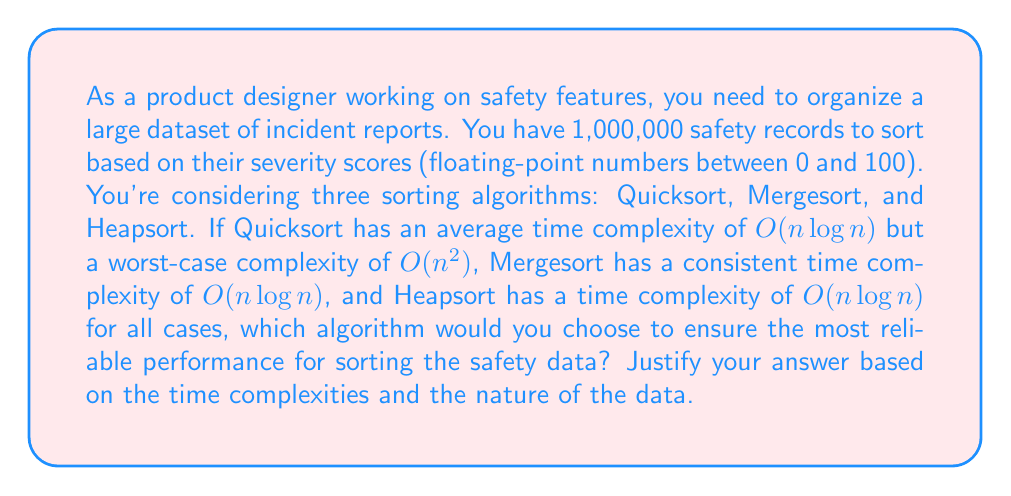Can you answer this question? To evaluate the performance of different sorting algorithms for organizing safety data, we need to consider both the time complexity and the nature of the data:

1. Quicksort:
   - Average case: $O(n \log n)$
   - Worst case: $O(n^2)$
   - Best for: Random data

2. Mergesort:
   - All cases: $O(n \log n)$
   - Best for: Linked lists, external sorting

3. Heapsort:
   - All cases: $O(n \log n)$
   - Best for: Arrays, limited memory

For 1,000,000 records:
- $n \log n \approx 1,000,000 \times \log_2(1,000,000) \approx 19,931,568$
- $n^2 = 1,000,000,000,000$

The worst-case scenario for Quicksort ($O(n^2)$) is significantly slower than the other algorithms. While Quicksort's average case is efficient, when dealing with safety data, reliability and consistency are crucial.

Both Mergesort and Heapsort guarantee $O(n \log n)$ performance in all cases, making them more reliable choices for safety-critical applications.

Heapsort has the advantage of sorting in-place, which is beneficial when dealing with large datasets and limited memory. It also has good cache performance, which can be important for large datasets.

Mergesort, while requiring additional space, is stable (preserves the relative order of equal elements) and performs well on linked lists, which could be beneficial if the data structure allows for easy insertion of new safety records.

Given the nature of safety data (critical information that needs reliable and consistent processing) and the large dataset size, Heapsort would be the most appropriate choice. It guarantees $O(n \log n)$ performance in all cases, sorts in-place (saving memory), and has good cache performance for large datasets.
Answer: Heapsort is the most suitable algorithm for sorting the safety data, as it guarantees $O(n \log n)$ time complexity in all cases, sorts in-place, and provides consistent performance for large datasets, which is crucial for reliable processing of safety-critical information. 